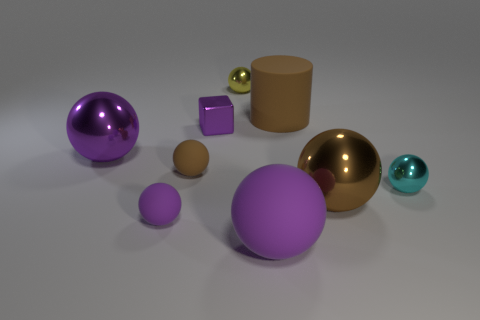Subtract all tiny cyan spheres. How many spheres are left? 6 Subtract all brown cylinders. How many brown spheres are left? 2 Subtract all brown spheres. How many spheres are left? 5 Add 1 tiny purple metallic objects. How many objects exist? 10 Subtract 3 balls. How many balls are left? 4 Subtract all cylinders. How many objects are left? 8 Subtract all yellow spheres. Subtract all gray cylinders. How many spheres are left? 6 Subtract 0 yellow blocks. How many objects are left? 9 Subtract all big cylinders. Subtract all yellow shiny balls. How many objects are left? 7 Add 6 big rubber things. How many big rubber things are left? 8 